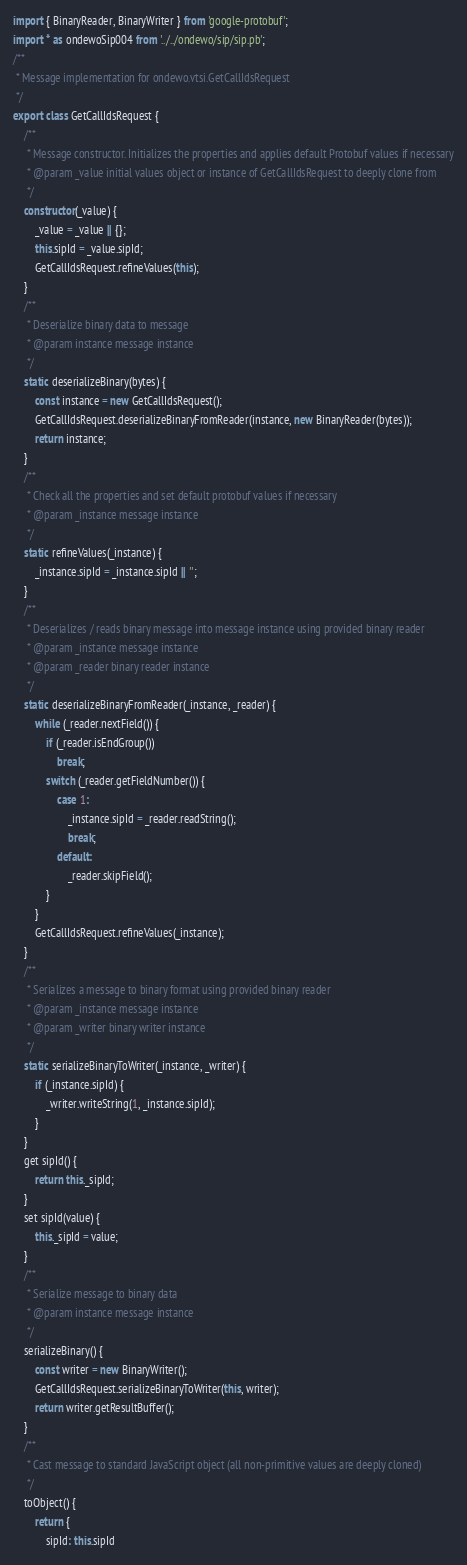Convert code to text. <code><loc_0><loc_0><loc_500><loc_500><_JavaScript_>import { BinaryReader, BinaryWriter } from 'google-protobuf';
import * as ondewoSip004 from '../../ondewo/sip/sip.pb';
/**
 * Message implementation for ondewo.vtsi.GetCallIdsRequest
 */
export class GetCallIdsRequest {
    /**
     * Message constructor. Initializes the properties and applies default Protobuf values if necessary
     * @param _value initial values object or instance of GetCallIdsRequest to deeply clone from
     */
    constructor(_value) {
        _value = _value || {};
        this.sipId = _value.sipId;
        GetCallIdsRequest.refineValues(this);
    }
    /**
     * Deserialize binary data to message
     * @param instance message instance
     */
    static deserializeBinary(bytes) {
        const instance = new GetCallIdsRequest();
        GetCallIdsRequest.deserializeBinaryFromReader(instance, new BinaryReader(bytes));
        return instance;
    }
    /**
     * Check all the properties and set default protobuf values if necessary
     * @param _instance message instance
     */
    static refineValues(_instance) {
        _instance.sipId = _instance.sipId || '';
    }
    /**
     * Deserializes / reads binary message into message instance using provided binary reader
     * @param _instance message instance
     * @param _reader binary reader instance
     */
    static deserializeBinaryFromReader(_instance, _reader) {
        while (_reader.nextField()) {
            if (_reader.isEndGroup())
                break;
            switch (_reader.getFieldNumber()) {
                case 1:
                    _instance.sipId = _reader.readString();
                    break;
                default:
                    _reader.skipField();
            }
        }
        GetCallIdsRequest.refineValues(_instance);
    }
    /**
     * Serializes a message to binary format using provided binary reader
     * @param _instance message instance
     * @param _writer binary writer instance
     */
    static serializeBinaryToWriter(_instance, _writer) {
        if (_instance.sipId) {
            _writer.writeString(1, _instance.sipId);
        }
    }
    get sipId() {
        return this._sipId;
    }
    set sipId(value) {
        this._sipId = value;
    }
    /**
     * Serialize message to binary data
     * @param instance message instance
     */
    serializeBinary() {
        const writer = new BinaryWriter();
        GetCallIdsRequest.serializeBinaryToWriter(this, writer);
        return writer.getResultBuffer();
    }
    /**
     * Cast message to standard JavaScript object (all non-primitive values are deeply cloned)
     */
    toObject() {
        return {
            sipId: this.sipId</code> 